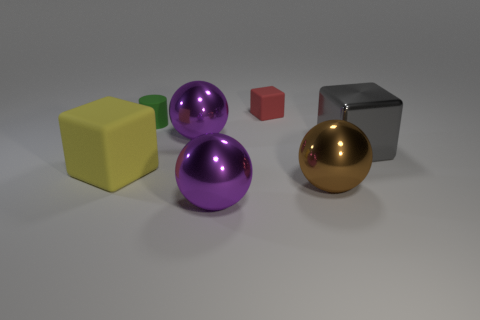There is a yellow cube that is made of the same material as the green cylinder; what size is it?
Give a very brief answer. Large. Does the matte object to the left of the small green rubber thing have the same shape as the red thing behind the brown thing?
Your response must be concise. Yes. There is a cube that is made of the same material as the red object; what color is it?
Your answer should be compact. Yellow. Is the size of the object that is behind the green rubber thing the same as the purple ball that is behind the large yellow rubber thing?
Provide a succinct answer. No. The object that is to the right of the tiny red block and behind the large rubber block has what shape?
Keep it short and to the point. Cube. Is there a small green cylinder that has the same material as the yellow cube?
Your answer should be compact. Yes. Is the purple thing in front of the gray cube made of the same material as the large cube that is in front of the gray metallic object?
Keep it short and to the point. No. Is the number of yellow objects greater than the number of large cubes?
Make the answer very short. No. The thing that is behind the tiny thing that is to the left of the large thing behind the large gray shiny cube is what color?
Make the answer very short. Red. Do the rubber cube to the left of the small red rubber cube and the small rubber thing on the right side of the small green matte cylinder have the same color?
Offer a very short reply. No. 